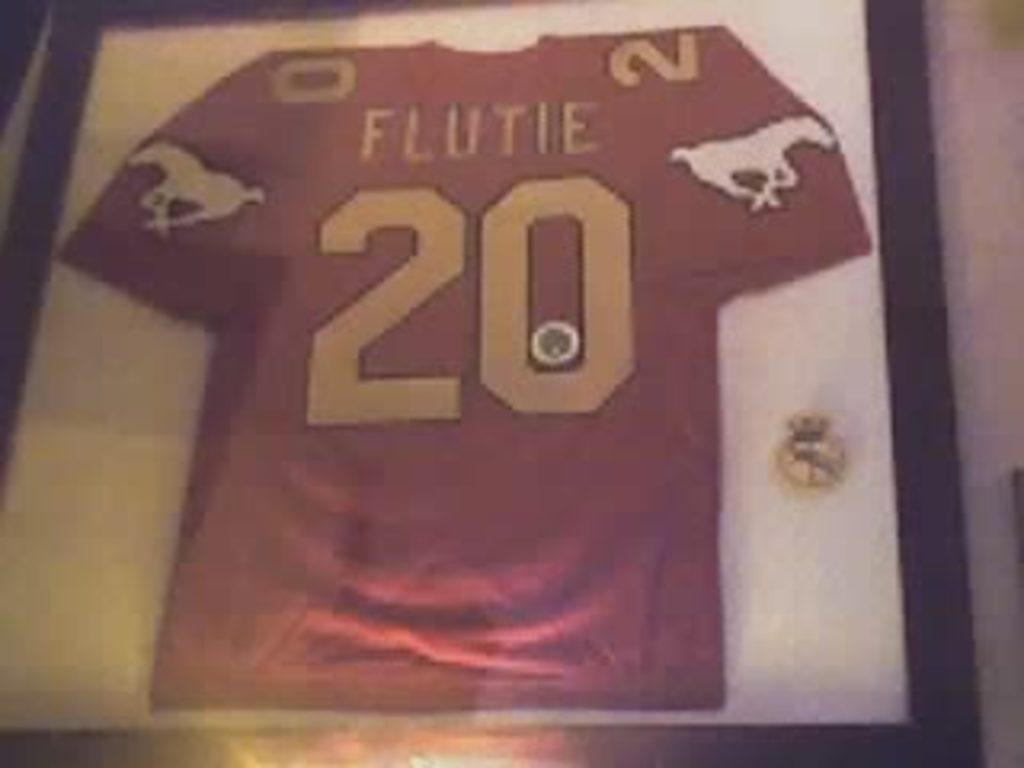<image>
Provide a brief description of the given image. number twenty jersey for a player named flutie 